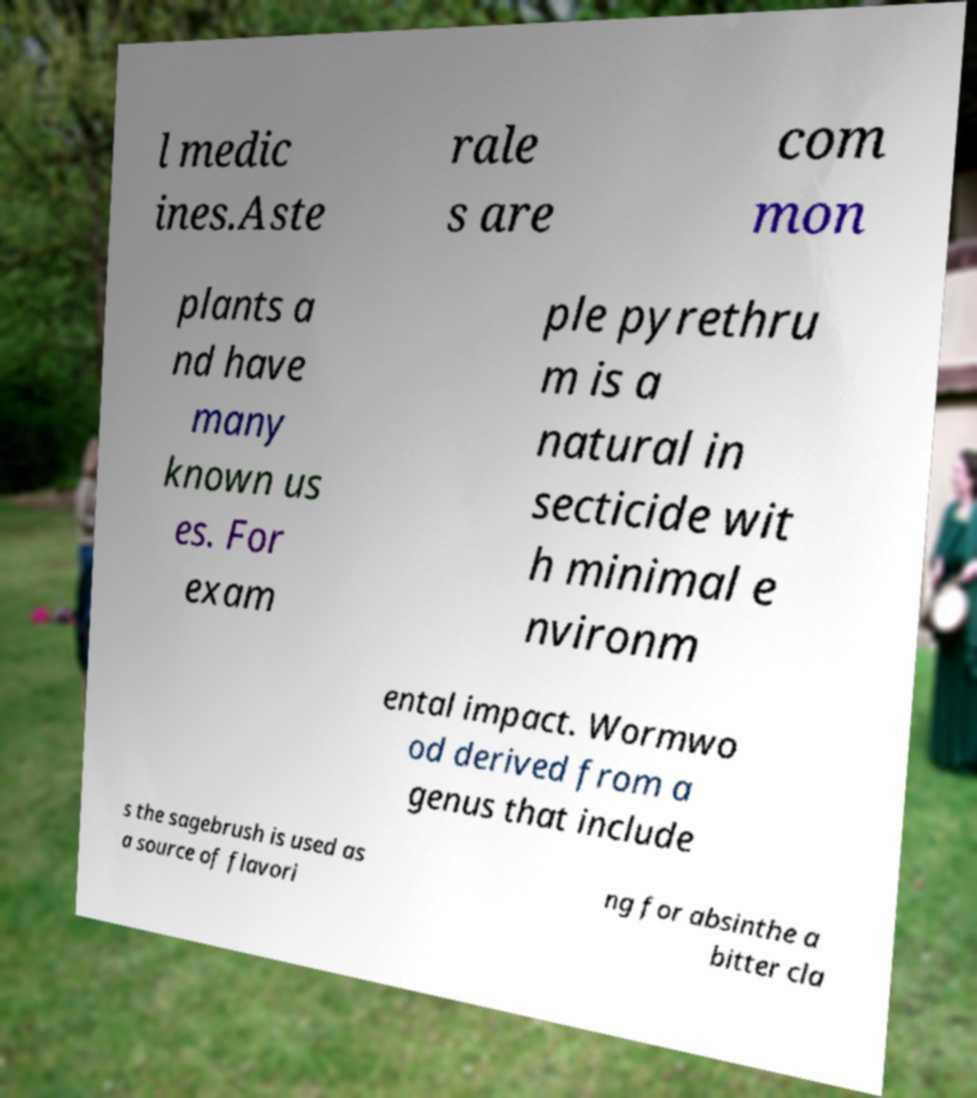What messages or text are displayed in this image? I need them in a readable, typed format. l medic ines.Aste rale s are com mon plants a nd have many known us es. For exam ple pyrethru m is a natural in secticide wit h minimal e nvironm ental impact. Wormwo od derived from a genus that include s the sagebrush is used as a source of flavori ng for absinthe a bitter cla 